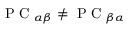Convert formula to latex. <formula><loc_0><loc_0><loc_500><loc_500>P C _ { \alpha \beta } \neq P C _ { \beta \alpha }</formula> 